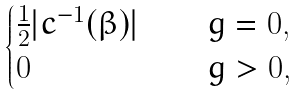Convert formula to latex. <formula><loc_0><loc_0><loc_500><loc_500>\begin{cases} \frac { 1 } { 2 } | c ^ { - 1 } ( \beta ) | & \quad g = 0 , \\ 0 & \quad g > 0 , \end{cases}</formula> 